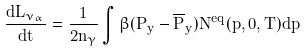<formula> <loc_0><loc_0><loc_500><loc_500>\frac { d L _ { \nu _ { \alpha } } } { d t } = \frac { 1 } { 2 n _ { \gamma } } \int \beta ( P _ { y } - \overline { P } _ { y } ) N ^ { e q } ( p , 0 , T ) d p</formula> 